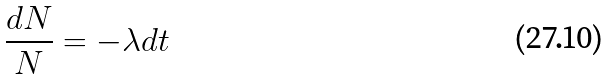<formula> <loc_0><loc_0><loc_500><loc_500>\frac { d N } { N } = - \lambda d t</formula> 